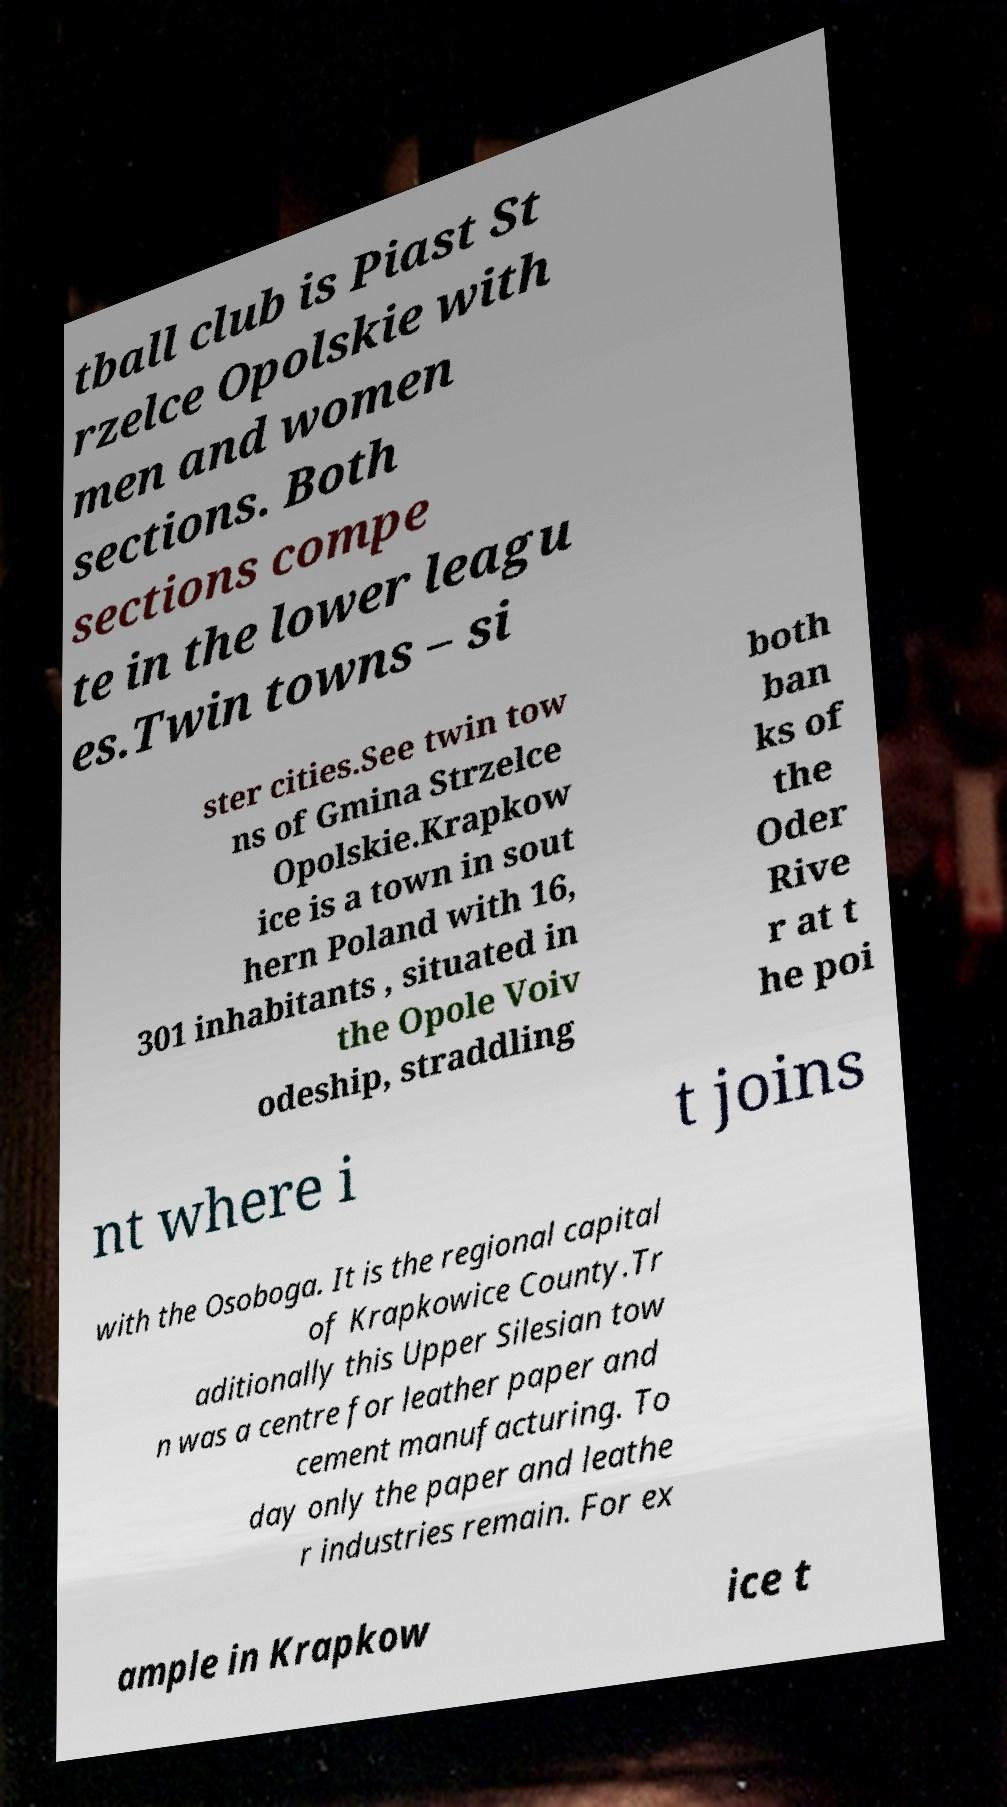What messages or text are displayed in this image? I need them in a readable, typed format. tball club is Piast St rzelce Opolskie with men and women sections. Both sections compe te in the lower leagu es.Twin towns – si ster cities.See twin tow ns of Gmina Strzelce Opolskie.Krapkow ice is a town in sout hern Poland with 16, 301 inhabitants , situated in the Opole Voiv odeship, straddling both ban ks of the Oder Rive r at t he poi nt where i t joins with the Osoboga. It is the regional capital of Krapkowice County.Tr aditionally this Upper Silesian tow n was a centre for leather paper and cement manufacturing. To day only the paper and leathe r industries remain. For ex ample in Krapkow ice t 